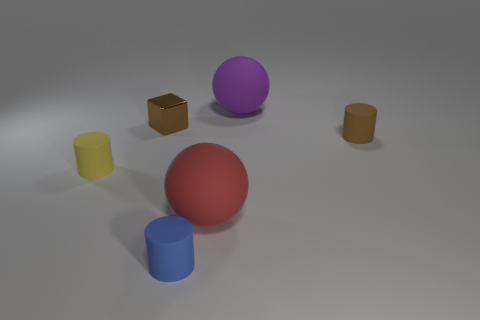Subtract all blue cylinders. How many cylinders are left? 2 Add 1 cubes. How many objects exist? 7 Subtract all blue cylinders. How many purple cubes are left? 0 Subtract all cubes. How many objects are left? 5 Subtract 0 gray cubes. How many objects are left? 6 Subtract 1 cubes. How many cubes are left? 0 Subtract all blue spheres. Subtract all purple cylinders. How many spheres are left? 2 Subtract all small metallic things. Subtract all small yellow rubber cylinders. How many objects are left? 4 Add 1 small cylinders. How many small cylinders are left? 4 Add 5 small cyan rubber cylinders. How many small cyan rubber cylinders exist? 5 